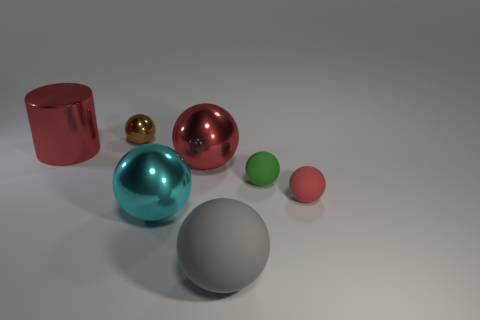Subtract all green spheres. How many spheres are left? 5 Subtract all red metallic spheres. How many spheres are left? 5 Subtract all green balls. Subtract all gray cylinders. How many balls are left? 5 Add 2 small red rubber cylinders. How many objects exist? 9 Subtract all cylinders. How many objects are left? 6 Add 6 red matte objects. How many red matte objects are left? 7 Add 5 small cyan things. How many small cyan things exist? 5 Subtract 1 cyan balls. How many objects are left? 6 Subtract all tiny metallic balls. Subtract all small brown spheres. How many objects are left? 5 